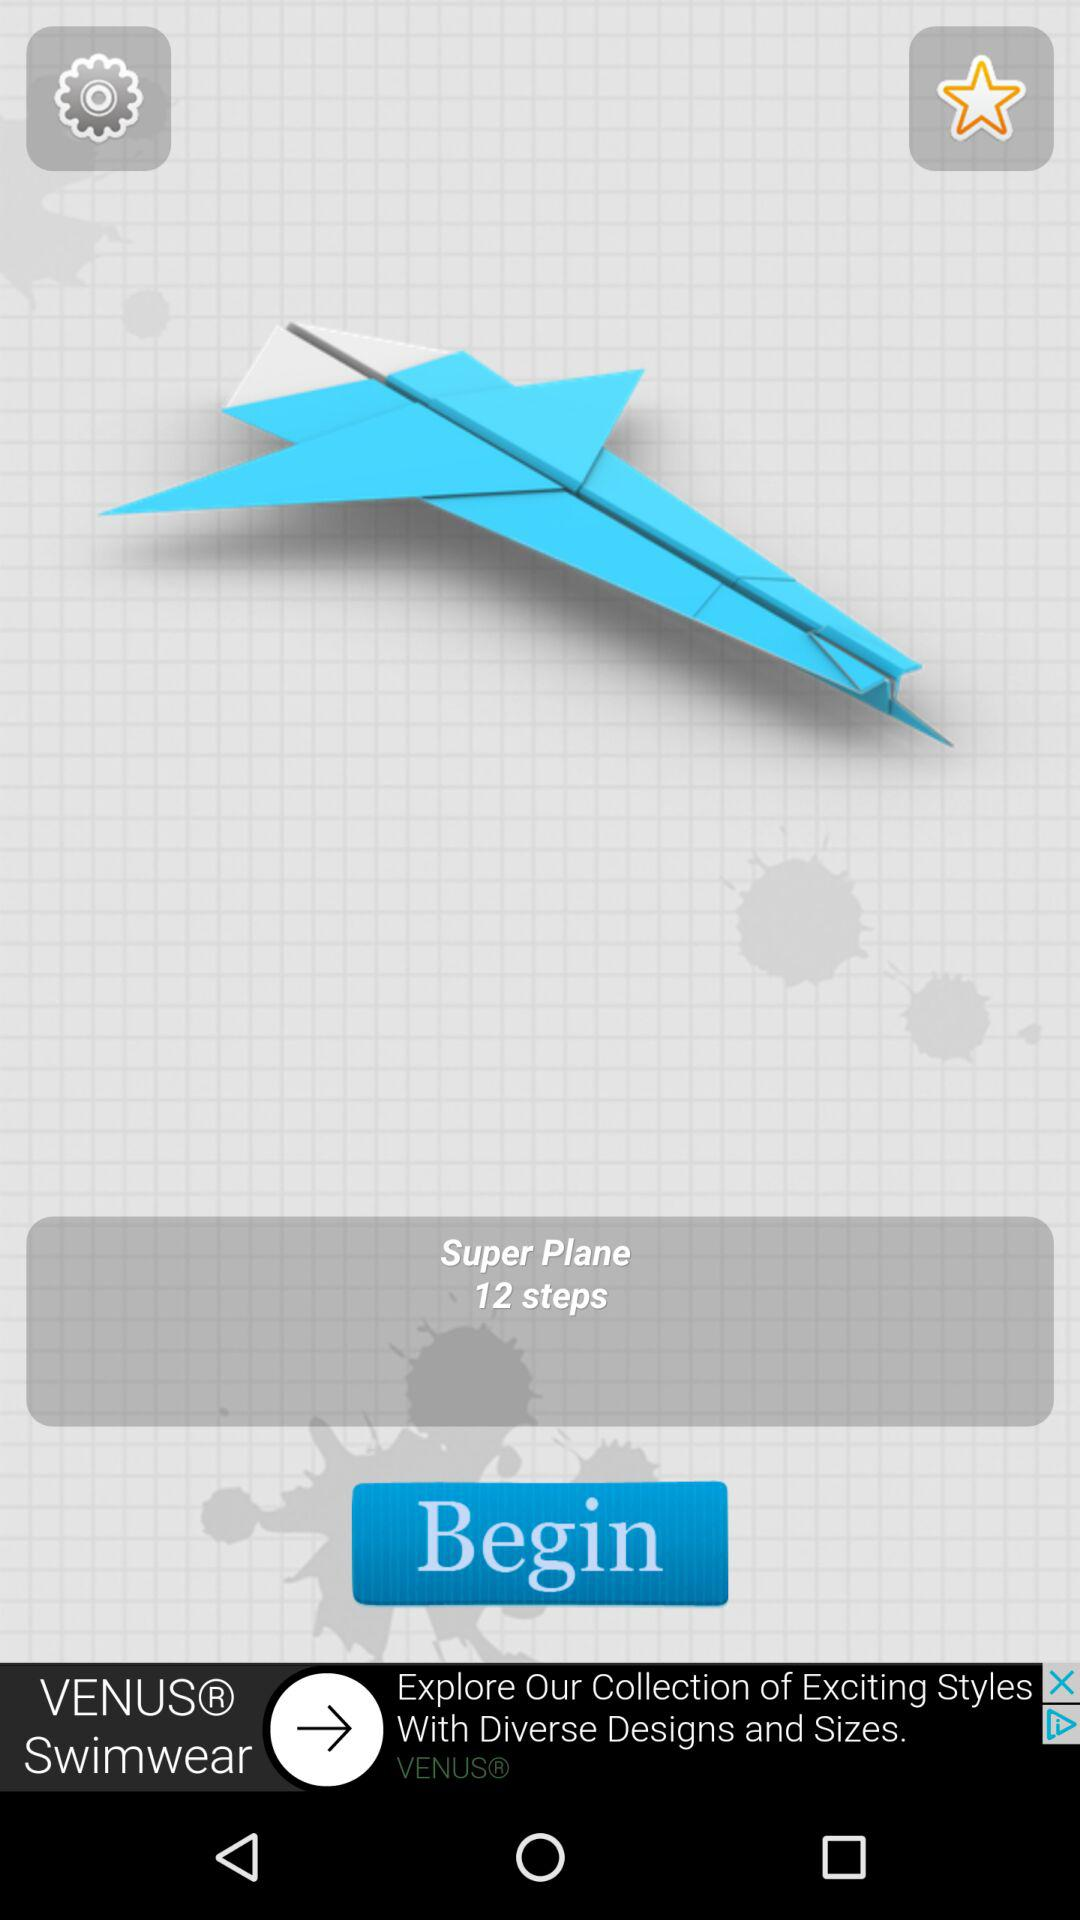How many steps are needed to make a "Super Plane"? The number of steps needed to make a "Super Plane" is 12. 